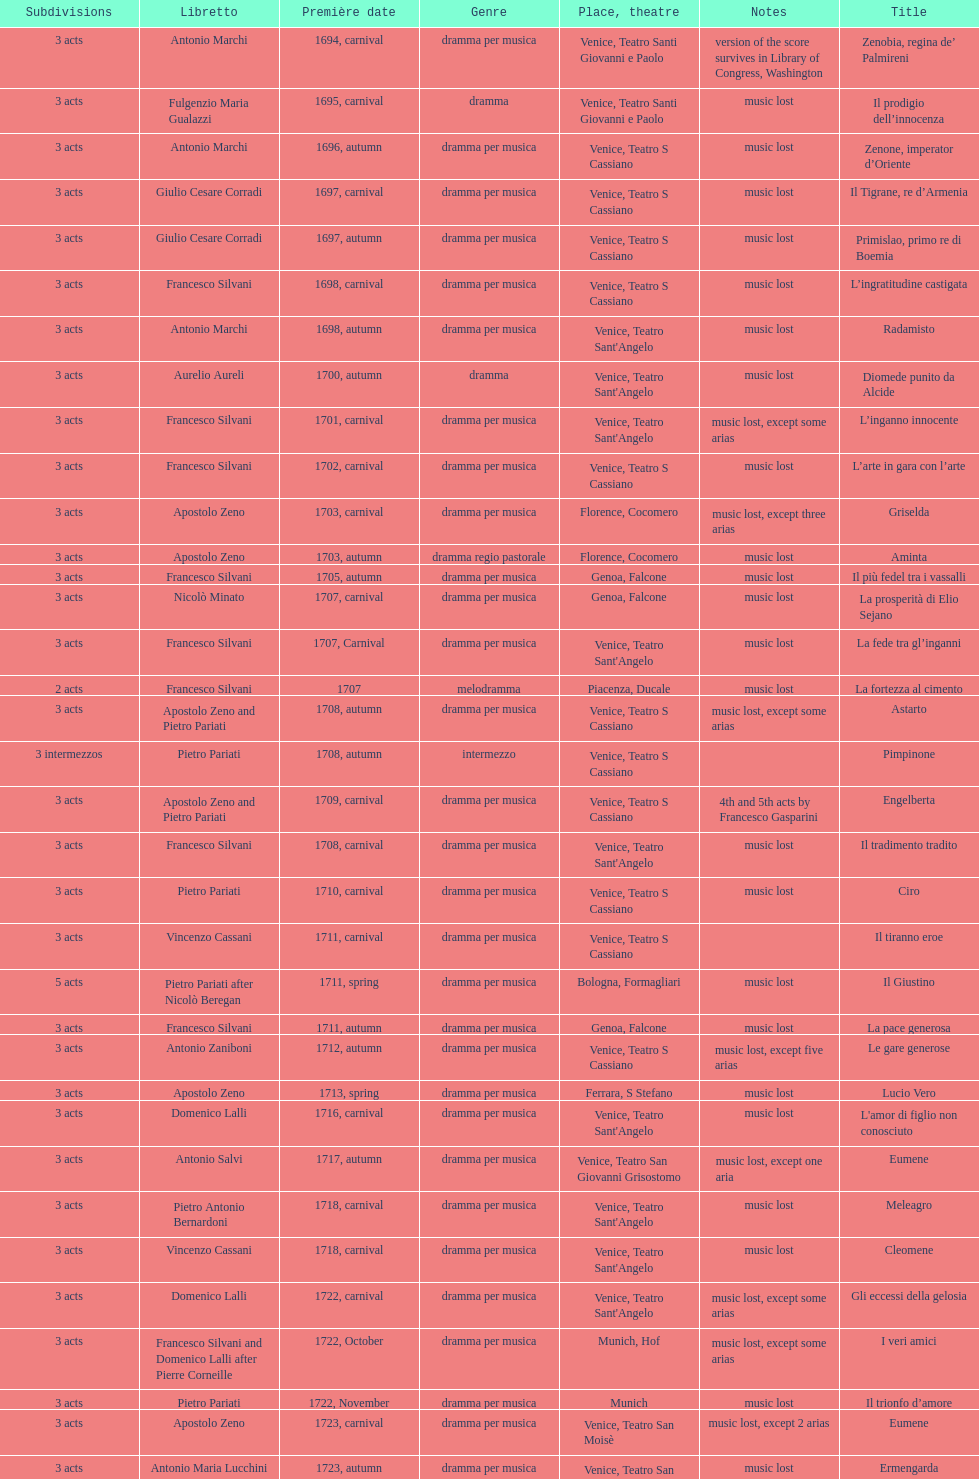How many were released after zenone, imperator d'oriente? 52. 